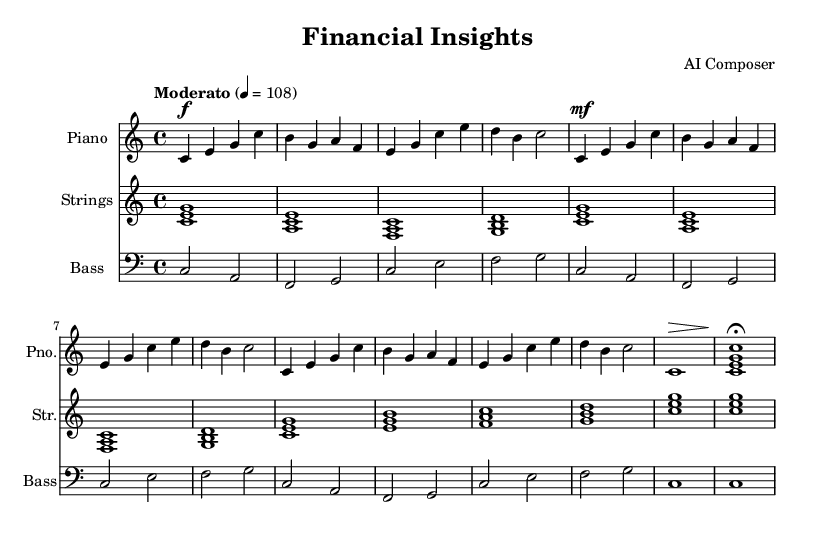What is the key signature of this music? The key signature is C major, which has no sharps or flats indicated. This can be determined by the absence of any sharp or flat symbols on the staff.
Answer: C major What is the time signature of the piece? The time signature is shown as 4/4 at the beginning, indicating four beats per measure and a quarter note gets one beat. This is often written as a fraction at the beginning of the music.
Answer: 4/4 What is the tempo marking for the piece? The tempo marking is "Moderato" with a metronome marking of 108. This indicates a moderate pace that should be maintained throughout the performance as specified at the start of the sheet music.
Answer: Moderato, 108 How many measures are in the main theme section? Counting the measures in the main theme leads to a total of four distinct measures presented in two repetitions. Each measure in the main theme contains a distinct melodic line delineated by vertical bar lines.
Answer: Four What instruments are utilized in this sheet music? The sheet music includes three distinct parts, specifically labeled for piano, strings, and bass. This information is indicated by the instrument names placed at the beginning of each staff in the score.
Answer: Piano, Strings, Bass What is the dynamics marking for the outro section? The dynamics in the outro change from a forte marking at the beginning to a piano marking indicated at the final note, specifically denoted by the symbols used in the last measures of each staff.
Answer: Piano How is the main theme structured musically? The main theme consists of repeated melodic phrases that build on one another, utilizing a combination of quarter notes and rhythmic variations, making it coherent and engaging throughout the indicated measures.
Answer: Repeated phrases 